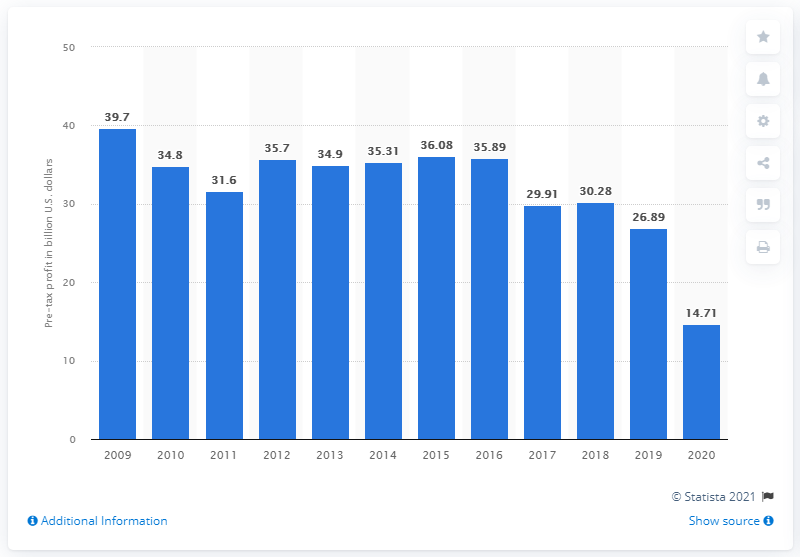Mention a couple of crucial points in this snapshot. The pre-tax pre-provision profit of Wells Fargo in 2020 was 14.71. 